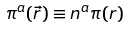Convert formula to latex. <formula><loc_0><loc_0><loc_500><loc_500>\pi ^ { a } ( \vec { r } ) \equiv n ^ { a } \pi ( r ) \,</formula> 